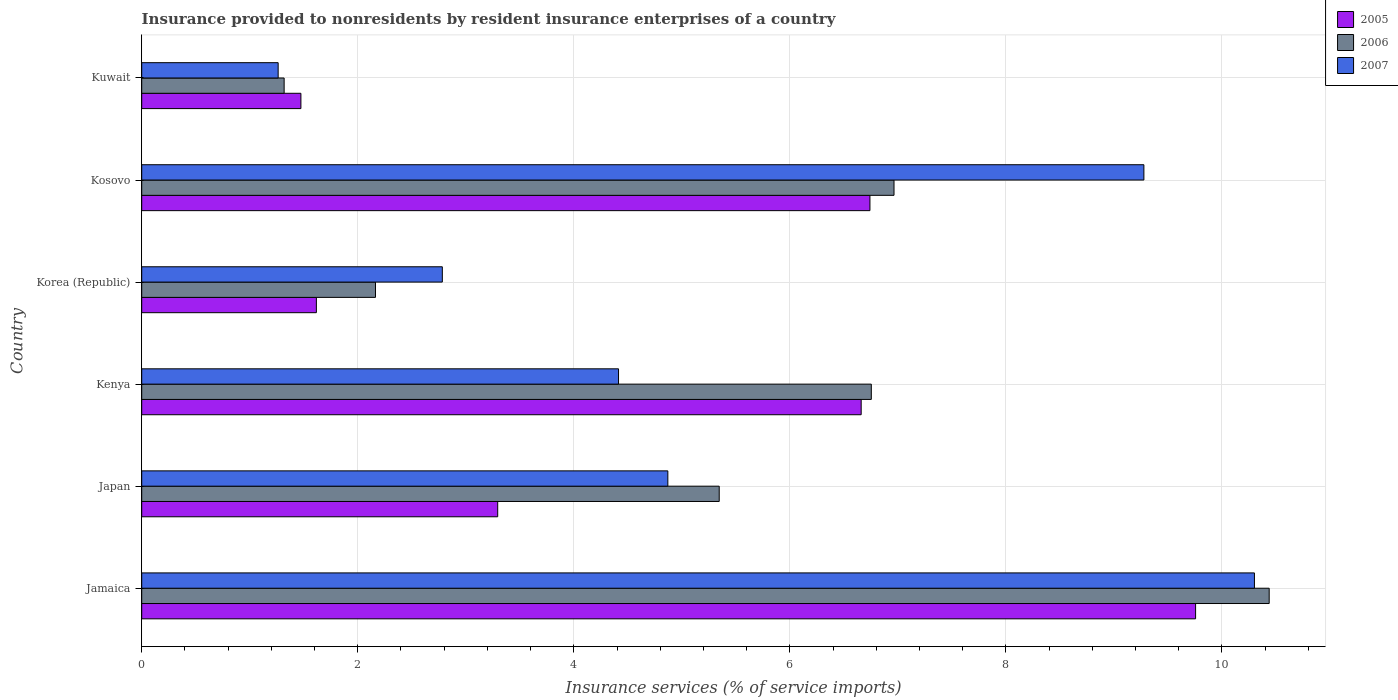Are the number of bars per tick equal to the number of legend labels?
Your answer should be very brief. Yes. What is the insurance provided to nonresidents in 2006 in Korea (Republic)?
Offer a very short reply. 2.16. Across all countries, what is the maximum insurance provided to nonresidents in 2005?
Ensure brevity in your answer.  9.76. Across all countries, what is the minimum insurance provided to nonresidents in 2006?
Offer a terse response. 1.32. In which country was the insurance provided to nonresidents in 2006 maximum?
Offer a terse response. Jamaica. In which country was the insurance provided to nonresidents in 2006 minimum?
Offer a terse response. Kuwait. What is the total insurance provided to nonresidents in 2006 in the graph?
Offer a terse response. 32.98. What is the difference between the insurance provided to nonresidents in 2005 in Jamaica and that in Kosovo?
Provide a short and direct response. 3.01. What is the difference between the insurance provided to nonresidents in 2005 in Japan and the insurance provided to nonresidents in 2006 in Kuwait?
Make the answer very short. 1.98. What is the average insurance provided to nonresidents in 2005 per country?
Keep it short and to the point. 4.92. What is the difference between the insurance provided to nonresidents in 2006 and insurance provided to nonresidents in 2005 in Jamaica?
Offer a terse response. 0.68. In how many countries, is the insurance provided to nonresidents in 2006 greater than 9.2 %?
Offer a terse response. 1. What is the ratio of the insurance provided to nonresidents in 2005 in Jamaica to that in Kuwait?
Ensure brevity in your answer.  6.62. Is the difference between the insurance provided to nonresidents in 2006 in Japan and Kuwait greater than the difference between the insurance provided to nonresidents in 2005 in Japan and Kuwait?
Make the answer very short. Yes. What is the difference between the highest and the second highest insurance provided to nonresidents in 2006?
Make the answer very short. 3.47. What is the difference between the highest and the lowest insurance provided to nonresidents in 2006?
Give a very brief answer. 9.12. What does the 2nd bar from the top in Jamaica represents?
Give a very brief answer. 2006. What does the 2nd bar from the bottom in Jamaica represents?
Offer a very short reply. 2006. How many countries are there in the graph?
Provide a succinct answer. 6. Does the graph contain any zero values?
Give a very brief answer. No. Does the graph contain grids?
Keep it short and to the point. Yes. What is the title of the graph?
Keep it short and to the point. Insurance provided to nonresidents by resident insurance enterprises of a country. Does "1961" appear as one of the legend labels in the graph?
Provide a short and direct response. No. What is the label or title of the X-axis?
Make the answer very short. Insurance services (% of service imports). What is the label or title of the Y-axis?
Offer a very short reply. Country. What is the Insurance services (% of service imports) of 2005 in Jamaica?
Ensure brevity in your answer.  9.76. What is the Insurance services (% of service imports) in 2006 in Jamaica?
Give a very brief answer. 10.44. What is the Insurance services (% of service imports) of 2007 in Jamaica?
Offer a terse response. 10.3. What is the Insurance services (% of service imports) in 2005 in Japan?
Your answer should be compact. 3.3. What is the Insurance services (% of service imports) of 2006 in Japan?
Provide a short and direct response. 5.35. What is the Insurance services (% of service imports) of 2007 in Japan?
Ensure brevity in your answer.  4.87. What is the Insurance services (% of service imports) in 2005 in Kenya?
Your answer should be compact. 6.66. What is the Insurance services (% of service imports) in 2006 in Kenya?
Offer a terse response. 6.75. What is the Insurance services (% of service imports) in 2007 in Kenya?
Make the answer very short. 4.41. What is the Insurance services (% of service imports) in 2005 in Korea (Republic)?
Your answer should be very brief. 1.62. What is the Insurance services (% of service imports) in 2006 in Korea (Republic)?
Offer a terse response. 2.16. What is the Insurance services (% of service imports) in 2007 in Korea (Republic)?
Make the answer very short. 2.78. What is the Insurance services (% of service imports) in 2005 in Kosovo?
Ensure brevity in your answer.  6.74. What is the Insurance services (% of service imports) in 2006 in Kosovo?
Offer a terse response. 6.96. What is the Insurance services (% of service imports) of 2007 in Kosovo?
Give a very brief answer. 9.28. What is the Insurance services (% of service imports) of 2005 in Kuwait?
Make the answer very short. 1.47. What is the Insurance services (% of service imports) of 2006 in Kuwait?
Keep it short and to the point. 1.32. What is the Insurance services (% of service imports) in 2007 in Kuwait?
Give a very brief answer. 1.26. Across all countries, what is the maximum Insurance services (% of service imports) of 2005?
Make the answer very short. 9.76. Across all countries, what is the maximum Insurance services (% of service imports) of 2006?
Ensure brevity in your answer.  10.44. Across all countries, what is the maximum Insurance services (% of service imports) in 2007?
Your response must be concise. 10.3. Across all countries, what is the minimum Insurance services (% of service imports) in 2005?
Your response must be concise. 1.47. Across all countries, what is the minimum Insurance services (% of service imports) in 2006?
Offer a terse response. 1.32. Across all countries, what is the minimum Insurance services (% of service imports) in 2007?
Offer a terse response. 1.26. What is the total Insurance services (% of service imports) in 2005 in the graph?
Give a very brief answer. 29.54. What is the total Insurance services (% of service imports) in 2006 in the graph?
Keep it short and to the point. 32.98. What is the total Insurance services (% of service imports) of 2007 in the graph?
Offer a terse response. 32.91. What is the difference between the Insurance services (% of service imports) of 2005 in Jamaica and that in Japan?
Provide a succinct answer. 6.46. What is the difference between the Insurance services (% of service imports) in 2006 in Jamaica and that in Japan?
Provide a short and direct response. 5.09. What is the difference between the Insurance services (% of service imports) in 2007 in Jamaica and that in Japan?
Keep it short and to the point. 5.43. What is the difference between the Insurance services (% of service imports) in 2005 in Jamaica and that in Kenya?
Ensure brevity in your answer.  3.1. What is the difference between the Insurance services (% of service imports) of 2006 in Jamaica and that in Kenya?
Make the answer very short. 3.68. What is the difference between the Insurance services (% of service imports) of 2007 in Jamaica and that in Kenya?
Offer a very short reply. 5.89. What is the difference between the Insurance services (% of service imports) in 2005 in Jamaica and that in Korea (Republic)?
Your answer should be very brief. 8.14. What is the difference between the Insurance services (% of service imports) in 2006 in Jamaica and that in Korea (Republic)?
Your answer should be compact. 8.27. What is the difference between the Insurance services (% of service imports) of 2007 in Jamaica and that in Korea (Republic)?
Give a very brief answer. 7.52. What is the difference between the Insurance services (% of service imports) of 2005 in Jamaica and that in Kosovo?
Your answer should be very brief. 3.01. What is the difference between the Insurance services (% of service imports) in 2006 in Jamaica and that in Kosovo?
Keep it short and to the point. 3.47. What is the difference between the Insurance services (% of service imports) of 2007 in Jamaica and that in Kosovo?
Offer a very short reply. 1.02. What is the difference between the Insurance services (% of service imports) of 2005 in Jamaica and that in Kuwait?
Keep it short and to the point. 8.28. What is the difference between the Insurance services (% of service imports) in 2006 in Jamaica and that in Kuwait?
Offer a very short reply. 9.12. What is the difference between the Insurance services (% of service imports) of 2007 in Jamaica and that in Kuwait?
Give a very brief answer. 9.04. What is the difference between the Insurance services (% of service imports) in 2005 in Japan and that in Kenya?
Ensure brevity in your answer.  -3.36. What is the difference between the Insurance services (% of service imports) in 2006 in Japan and that in Kenya?
Ensure brevity in your answer.  -1.41. What is the difference between the Insurance services (% of service imports) of 2007 in Japan and that in Kenya?
Provide a short and direct response. 0.46. What is the difference between the Insurance services (% of service imports) of 2005 in Japan and that in Korea (Republic)?
Provide a short and direct response. 1.68. What is the difference between the Insurance services (% of service imports) of 2006 in Japan and that in Korea (Republic)?
Your response must be concise. 3.18. What is the difference between the Insurance services (% of service imports) of 2007 in Japan and that in Korea (Republic)?
Keep it short and to the point. 2.09. What is the difference between the Insurance services (% of service imports) of 2005 in Japan and that in Kosovo?
Your answer should be compact. -3.45. What is the difference between the Insurance services (% of service imports) in 2006 in Japan and that in Kosovo?
Make the answer very short. -1.62. What is the difference between the Insurance services (% of service imports) in 2007 in Japan and that in Kosovo?
Ensure brevity in your answer.  -4.41. What is the difference between the Insurance services (% of service imports) in 2005 in Japan and that in Kuwait?
Offer a terse response. 1.82. What is the difference between the Insurance services (% of service imports) in 2006 in Japan and that in Kuwait?
Give a very brief answer. 4.03. What is the difference between the Insurance services (% of service imports) in 2007 in Japan and that in Kuwait?
Your answer should be very brief. 3.61. What is the difference between the Insurance services (% of service imports) in 2005 in Kenya and that in Korea (Republic)?
Provide a succinct answer. 5.04. What is the difference between the Insurance services (% of service imports) in 2006 in Kenya and that in Korea (Republic)?
Provide a short and direct response. 4.59. What is the difference between the Insurance services (% of service imports) of 2007 in Kenya and that in Korea (Republic)?
Ensure brevity in your answer.  1.63. What is the difference between the Insurance services (% of service imports) of 2005 in Kenya and that in Kosovo?
Your answer should be compact. -0.08. What is the difference between the Insurance services (% of service imports) of 2006 in Kenya and that in Kosovo?
Make the answer very short. -0.21. What is the difference between the Insurance services (% of service imports) in 2007 in Kenya and that in Kosovo?
Your response must be concise. -4.86. What is the difference between the Insurance services (% of service imports) of 2005 in Kenya and that in Kuwait?
Keep it short and to the point. 5.19. What is the difference between the Insurance services (% of service imports) of 2006 in Kenya and that in Kuwait?
Give a very brief answer. 5.44. What is the difference between the Insurance services (% of service imports) of 2007 in Kenya and that in Kuwait?
Offer a very short reply. 3.15. What is the difference between the Insurance services (% of service imports) of 2005 in Korea (Republic) and that in Kosovo?
Offer a very short reply. -5.12. What is the difference between the Insurance services (% of service imports) in 2006 in Korea (Republic) and that in Kosovo?
Keep it short and to the point. -4.8. What is the difference between the Insurance services (% of service imports) of 2007 in Korea (Republic) and that in Kosovo?
Your response must be concise. -6.49. What is the difference between the Insurance services (% of service imports) of 2005 in Korea (Republic) and that in Kuwait?
Offer a very short reply. 0.14. What is the difference between the Insurance services (% of service imports) of 2006 in Korea (Republic) and that in Kuwait?
Your answer should be compact. 0.85. What is the difference between the Insurance services (% of service imports) in 2007 in Korea (Republic) and that in Kuwait?
Offer a terse response. 1.52. What is the difference between the Insurance services (% of service imports) of 2005 in Kosovo and that in Kuwait?
Your response must be concise. 5.27. What is the difference between the Insurance services (% of service imports) in 2006 in Kosovo and that in Kuwait?
Offer a very short reply. 5.65. What is the difference between the Insurance services (% of service imports) of 2007 in Kosovo and that in Kuwait?
Provide a short and direct response. 8.01. What is the difference between the Insurance services (% of service imports) of 2005 in Jamaica and the Insurance services (% of service imports) of 2006 in Japan?
Provide a succinct answer. 4.41. What is the difference between the Insurance services (% of service imports) of 2005 in Jamaica and the Insurance services (% of service imports) of 2007 in Japan?
Your response must be concise. 4.89. What is the difference between the Insurance services (% of service imports) in 2006 in Jamaica and the Insurance services (% of service imports) in 2007 in Japan?
Provide a short and direct response. 5.57. What is the difference between the Insurance services (% of service imports) in 2005 in Jamaica and the Insurance services (% of service imports) in 2006 in Kenya?
Give a very brief answer. 3. What is the difference between the Insurance services (% of service imports) of 2005 in Jamaica and the Insurance services (% of service imports) of 2007 in Kenya?
Ensure brevity in your answer.  5.34. What is the difference between the Insurance services (% of service imports) in 2006 in Jamaica and the Insurance services (% of service imports) in 2007 in Kenya?
Give a very brief answer. 6.02. What is the difference between the Insurance services (% of service imports) in 2005 in Jamaica and the Insurance services (% of service imports) in 2006 in Korea (Republic)?
Ensure brevity in your answer.  7.59. What is the difference between the Insurance services (% of service imports) of 2005 in Jamaica and the Insurance services (% of service imports) of 2007 in Korea (Republic)?
Ensure brevity in your answer.  6.97. What is the difference between the Insurance services (% of service imports) in 2006 in Jamaica and the Insurance services (% of service imports) in 2007 in Korea (Republic)?
Make the answer very short. 7.65. What is the difference between the Insurance services (% of service imports) in 2005 in Jamaica and the Insurance services (% of service imports) in 2006 in Kosovo?
Ensure brevity in your answer.  2.79. What is the difference between the Insurance services (% of service imports) in 2005 in Jamaica and the Insurance services (% of service imports) in 2007 in Kosovo?
Provide a short and direct response. 0.48. What is the difference between the Insurance services (% of service imports) of 2006 in Jamaica and the Insurance services (% of service imports) of 2007 in Kosovo?
Provide a succinct answer. 1.16. What is the difference between the Insurance services (% of service imports) in 2005 in Jamaica and the Insurance services (% of service imports) in 2006 in Kuwait?
Offer a terse response. 8.44. What is the difference between the Insurance services (% of service imports) in 2005 in Jamaica and the Insurance services (% of service imports) in 2007 in Kuwait?
Make the answer very short. 8.49. What is the difference between the Insurance services (% of service imports) of 2006 in Jamaica and the Insurance services (% of service imports) of 2007 in Kuwait?
Your answer should be very brief. 9.17. What is the difference between the Insurance services (% of service imports) in 2005 in Japan and the Insurance services (% of service imports) in 2006 in Kenya?
Give a very brief answer. -3.46. What is the difference between the Insurance services (% of service imports) of 2005 in Japan and the Insurance services (% of service imports) of 2007 in Kenya?
Provide a succinct answer. -1.12. What is the difference between the Insurance services (% of service imports) of 2006 in Japan and the Insurance services (% of service imports) of 2007 in Kenya?
Your response must be concise. 0.93. What is the difference between the Insurance services (% of service imports) of 2005 in Japan and the Insurance services (% of service imports) of 2006 in Korea (Republic)?
Your answer should be compact. 1.13. What is the difference between the Insurance services (% of service imports) of 2005 in Japan and the Insurance services (% of service imports) of 2007 in Korea (Republic)?
Offer a very short reply. 0.51. What is the difference between the Insurance services (% of service imports) of 2006 in Japan and the Insurance services (% of service imports) of 2007 in Korea (Republic)?
Offer a very short reply. 2.56. What is the difference between the Insurance services (% of service imports) in 2005 in Japan and the Insurance services (% of service imports) in 2006 in Kosovo?
Ensure brevity in your answer.  -3.67. What is the difference between the Insurance services (% of service imports) in 2005 in Japan and the Insurance services (% of service imports) in 2007 in Kosovo?
Make the answer very short. -5.98. What is the difference between the Insurance services (% of service imports) in 2006 in Japan and the Insurance services (% of service imports) in 2007 in Kosovo?
Keep it short and to the point. -3.93. What is the difference between the Insurance services (% of service imports) in 2005 in Japan and the Insurance services (% of service imports) in 2006 in Kuwait?
Provide a succinct answer. 1.98. What is the difference between the Insurance services (% of service imports) of 2005 in Japan and the Insurance services (% of service imports) of 2007 in Kuwait?
Ensure brevity in your answer.  2.03. What is the difference between the Insurance services (% of service imports) of 2006 in Japan and the Insurance services (% of service imports) of 2007 in Kuwait?
Your response must be concise. 4.08. What is the difference between the Insurance services (% of service imports) in 2005 in Kenya and the Insurance services (% of service imports) in 2006 in Korea (Republic)?
Make the answer very short. 4.5. What is the difference between the Insurance services (% of service imports) in 2005 in Kenya and the Insurance services (% of service imports) in 2007 in Korea (Republic)?
Provide a short and direct response. 3.88. What is the difference between the Insurance services (% of service imports) of 2006 in Kenya and the Insurance services (% of service imports) of 2007 in Korea (Republic)?
Your answer should be compact. 3.97. What is the difference between the Insurance services (% of service imports) in 2005 in Kenya and the Insurance services (% of service imports) in 2006 in Kosovo?
Your answer should be very brief. -0.3. What is the difference between the Insurance services (% of service imports) of 2005 in Kenya and the Insurance services (% of service imports) of 2007 in Kosovo?
Provide a succinct answer. -2.62. What is the difference between the Insurance services (% of service imports) in 2006 in Kenya and the Insurance services (% of service imports) in 2007 in Kosovo?
Your response must be concise. -2.52. What is the difference between the Insurance services (% of service imports) of 2005 in Kenya and the Insurance services (% of service imports) of 2006 in Kuwait?
Your answer should be very brief. 5.34. What is the difference between the Insurance services (% of service imports) of 2005 in Kenya and the Insurance services (% of service imports) of 2007 in Kuwait?
Your response must be concise. 5.4. What is the difference between the Insurance services (% of service imports) of 2006 in Kenya and the Insurance services (% of service imports) of 2007 in Kuwait?
Provide a succinct answer. 5.49. What is the difference between the Insurance services (% of service imports) of 2005 in Korea (Republic) and the Insurance services (% of service imports) of 2006 in Kosovo?
Your answer should be very brief. -5.35. What is the difference between the Insurance services (% of service imports) of 2005 in Korea (Republic) and the Insurance services (% of service imports) of 2007 in Kosovo?
Offer a terse response. -7.66. What is the difference between the Insurance services (% of service imports) in 2006 in Korea (Republic) and the Insurance services (% of service imports) in 2007 in Kosovo?
Make the answer very short. -7.11. What is the difference between the Insurance services (% of service imports) of 2005 in Korea (Republic) and the Insurance services (% of service imports) of 2006 in Kuwait?
Offer a very short reply. 0.3. What is the difference between the Insurance services (% of service imports) in 2005 in Korea (Republic) and the Insurance services (% of service imports) in 2007 in Kuwait?
Provide a succinct answer. 0.35. What is the difference between the Insurance services (% of service imports) of 2006 in Korea (Republic) and the Insurance services (% of service imports) of 2007 in Kuwait?
Give a very brief answer. 0.9. What is the difference between the Insurance services (% of service imports) in 2005 in Kosovo and the Insurance services (% of service imports) in 2006 in Kuwait?
Provide a short and direct response. 5.42. What is the difference between the Insurance services (% of service imports) of 2005 in Kosovo and the Insurance services (% of service imports) of 2007 in Kuwait?
Keep it short and to the point. 5.48. What is the difference between the Insurance services (% of service imports) of 2006 in Kosovo and the Insurance services (% of service imports) of 2007 in Kuwait?
Your answer should be compact. 5.7. What is the average Insurance services (% of service imports) in 2005 per country?
Provide a succinct answer. 4.92. What is the average Insurance services (% of service imports) in 2006 per country?
Your response must be concise. 5.5. What is the average Insurance services (% of service imports) in 2007 per country?
Offer a very short reply. 5.48. What is the difference between the Insurance services (% of service imports) of 2005 and Insurance services (% of service imports) of 2006 in Jamaica?
Make the answer very short. -0.68. What is the difference between the Insurance services (% of service imports) in 2005 and Insurance services (% of service imports) in 2007 in Jamaica?
Offer a terse response. -0.54. What is the difference between the Insurance services (% of service imports) of 2006 and Insurance services (% of service imports) of 2007 in Jamaica?
Make the answer very short. 0.14. What is the difference between the Insurance services (% of service imports) of 2005 and Insurance services (% of service imports) of 2006 in Japan?
Provide a succinct answer. -2.05. What is the difference between the Insurance services (% of service imports) in 2005 and Insurance services (% of service imports) in 2007 in Japan?
Make the answer very short. -1.58. What is the difference between the Insurance services (% of service imports) in 2006 and Insurance services (% of service imports) in 2007 in Japan?
Provide a succinct answer. 0.48. What is the difference between the Insurance services (% of service imports) in 2005 and Insurance services (% of service imports) in 2006 in Kenya?
Provide a succinct answer. -0.09. What is the difference between the Insurance services (% of service imports) of 2005 and Insurance services (% of service imports) of 2007 in Kenya?
Provide a succinct answer. 2.25. What is the difference between the Insurance services (% of service imports) in 2006 and Insurance services (% of service imports) in 2007 in Kenya?
Ensure brevity in your answer.  2.34. What is the difference between the Insurance services (% of service imports) in 2005 and Insurance services (% of service imports) in 2006 in Korea (Republic)?
Your answer should be very brief. -0.55. What is the difference between the Insurance services (% of service imports) in 2005 and Insurance services (% of service imports) in 2007 in Korea (Republic)?
Provide a succinct answer. -1.17. What is the difference between the Insurance services (% of service imports) in 2006 and Insurance services (% of service imports) in 2007 in Korea (Republic)?
Your answer should be compact. -0.62. What is the difference between the Insurance services (% of service imports) in 2005 and Insurance services (% of service imports) in 2006 in Kosovo?
Ensure brevity in your answer.  -0.22. What is the difference between the Insurance services (% of service imports) in 2005 and Insurance services (% of service imports) in 2007 in Kosovo?
Give a very brief answer. -2.54. What is the difference between the Insurance services (% of service imports) of 2006 and Insurance services (% of service imports) of 2007 in Kosovo?
Provide a short and direct response. -2.31. What is the difference between the Insurance services (% of service imports) of 2005 and Insurance services (% of service imports) of 2006 in Kuwait?
Provide a succinct answer. 0.16. What is the difference between the Insurance services (% of service imports) of 2005 and Insurance services (% of service imports) of 2007 in Kuwait?
Keep it short and to the point. 0.21. What is the difference between the Insurance services (% of service imports) in 2006 and Insurance services (% of service imports) in 2007 in Kuwait?
Ensure brevity in your answer.  0.06. What is the ratio of the Insurance services (% of service imports) of 2005 in Jamaica to that in Japan?
Your answer should be compact. 2.96. What is the ratio of the Insurance services (% of service imports) of 2006 in Jamaica to that in Japan?
Give a very brief answer. 1.95. What is the ratio of the Insurance services (% of service imports) of 2007 in Jamaica to that in Japan?
Give a very brief answer. 2.11. What is the ratio of the Insurance services (% of service imports) in 2005 in Jamaica to that in Kenya?
Your response must be concise. 1.46. What is the ratio of the Insurance services (% of service imports) of 2006 in Jamaica to that in Kenya?
Give a very brief answer. 1.55. What is the ratio of the Insurance services (% of service imports) in 2007 in Jamaica to that in Kenya?
Offer a very short reply. 2.33. What is the ratio of the Insurance services (% of service imports) of 2005 in Jamaica to that in Korea (Republic)?
Provide a short and direct response. 6.03. What is the ratio of the Insurance services (% of service imports) of 2006 in Jamaica to that in Korea (Republic)?
Your answer should be compact. 4.82. What is the ratio of the Insurance services (% of service imports) in 2007 in Jamaica to that in Korea (Republic)?
Your response must be concise. 3.7. What is the ratio of the Insurance services (% of service imports) in 2005 in Jamaica to that in Kosovo?
Your answer should be very brief. 1.45. What is the ratio of the Insurance services (% of service imports) in 2006 in Jamaica to that in Kosovo?
Keep it short and to the point. 1.5. What is the ratio of the Insurance services (% of service imports) of 2007 in Jamaica to that in Kosovo?
Offer a terse response. 1.11. What is the ratio of the Insurance services (% of service imports) of 2005 in Jamaica to that in Kuwait?
Your response must be concise. 6.62. What is the ratio of the Insurance services (% of service imports) of 2006 in Jamaica to that in Kuwait?
Provide a short and direct response. 7.92. What is the ratio of the Insurance services (% of service imports) in 2007 in Jamaica to that in Kuwait?
Your answer should be very brief. 8.16. What is the ratio of the Insurance services (% of service imports) of 2005 in Japan to that in Kenya?
Your answer should be compact. 0.49. What is the ratio of the Insurance services (% of service imports) in 2006 in Japan to that in Kenya?
Your answer should be compact. 0.79. What is the ratio of the Insurance services (% of service imports) of 2007 in Japan to that in Kenya?
Ensure brevity in your answer.  1.1. What is the ratio of the Insurance services (% of service imports) in 2005 in Japan to that in Korea (Republic)?
Your answer should be compact. 2.04. What is the ratio of the Insurance services (% of service imports) of 2006 in Japan to that in Korea (Republic)?
Offer a terse response. 2.47. What is the ratio of the Insurance services (% of service imports) of 2007 in Japan to that in Korea (Republic)?
Keep it short and to the point. 1.75. What is the ratio of the Insurance services (% of service imports) of 2005 in Japan to that in Kosovo?
Your response must be concise. 0.49. What is the ratio of the Insurance services (% of service imports) of 2006 in Japan to that in Kosovo?
Ensure brevity in your answer.  0.77. What is the ratio of the Insurance services (% of service imports) of 2007 in Japan to that in Kosovo?
Offer a terse response. 0.53. What is the ratio of the Insurance services (% of service imports) in 2005 in Japan to that in Kuwait?
Offer a very short reply. 2.24. What is the ratio of the Insurance services (% of service imports) in 2006 in Japan to that in Kuwait?
Offer a very short reply. 4.05. What is the ratio of the Insurance services (% of service imports) of 2007 in Japan to that in Kuwait?
Give a very brief answer. 3.86. What is the ratio of the Insurance services (% of service imports) in 2005 in Kenya to that in Korea (Republic)?
Give a very brief answer. 4.12. What is the ratio of the Insurance services (% of service imports) in 2006 in Kenya to that in Korea (Republic)?
Ensure brevity in your answer.  3.12. What is the ratio of the Insurance services (% of service imports) of 2007 in Kenya to that in Korea (Republic)?
Give a very brief answer. 1.59. What is the ratio of the Insurance services (% of service imports) of 2005 in Kenya to that in Kosovo?
Give a very brief answer. 0.99. What is the ratio of the Insurance services (% of service imports) in 2006 in Kenya to that in Kosovo?
Your answer should be very brief. 0.97. What is the ratio of the Insurance services (% of service imports) of 2007 in Kenya to that in Kosovo?
Offer a very short reply. 0.48. What is the ratio of the Insurance services (% of service imports) in 2005 in Kenya to that in Kuwait?
Offer a terse response. 4.52. What is the ratio of the Insurance services (% of service imports) in 2006 in Kenya to that in Kuwait?
Give a very brief answer. 5.12. What is the ratio of the Insurance services (% of service imports) in 2007 in Kenya to that in Kuwait?
Keep it short and to the point. 3.49. What is the ratio of the Insurance services (% of service imports) of 2005 in Korea (Republic) to that in Kosovo?
Your response must be concise. 0.24. What is the ratio of the Insurance services (% of service imports) of 2006 in Korea (Republic) to that in Kosovo?
Ensure brevity in your answer.  0.31. What is the ratio of the Insurance services (% of service imports) of 2007 in Korea (Republic) to that in Kosovo?
Your answer should be compact. 0.3. What is the ratio of the Insurance services (% of service imports) in 2005 in Korea (Republic) to that in Kuwait?
Your answer should be very brief. 1.1. What is the ratio of the Insurance services (% of service imports) in 2006 in Korea (Republic) to that in Kuwait?
Offer a very short reply. 1.64. What is the ratio of the Insurance services (% of service imports) of 2007 in Korea (Republic) to that in Kuwait?
Your answer should be compact. 2.2. What is the ratio of the Insurance services (% of service imports) in 2005 in Kosovo to that in Kuwait?
Your answer should be compact. 4.57. What is the ratio of the Insurance services (% of service imports) in 2006 in Kosovo to that in Kuwait?
Give a very brief answer. 5.28. What is the ratio of the Insurance services (% of service imports) in 2007 in Kosovo to that in Kuwait?
Provide a short and direct response. 7.35. What is the difference between the highest and the second highest Insurance services (% of service imports) in 2005?
Keep it short and to the point. 3.01. What is the difference between the highest and the second highest Insurance services (% of service imports) of 2006?
Your answer should be very brief. 3.47. What is the difference between the highest and the second highest Insurance services (% of service imports) in 2007?
Your answer should be very brief. 1.02. What is the difference between the highest and the lowest Insurance services (% of service imports) of 2005?
Make the answer very short. 8.28. What is the difference between the highest and the lowest Insurance services (% of service imports) of 2006?
Your answer should be compact. 9.12. What is the difference between the highest and the lowest Insurance services (% of service imports) in 2007?
Ensure brevity in your answer.  9.04. 